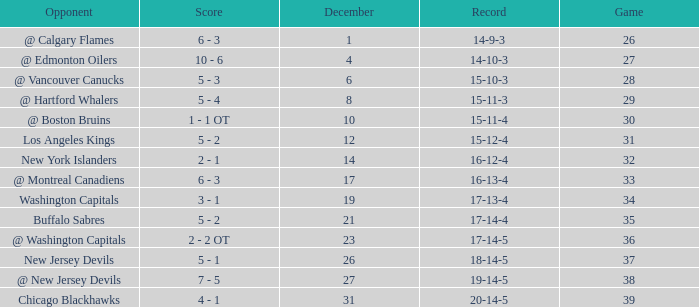Record of 15-12-4, and a Game larger than 31 involves what highest December? None. 